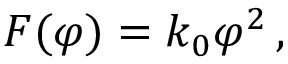<formula> <loc_0><loc_0><loc_500><loc_500>F ( \varphi ) = k _ { 0 } { \varphi } ^ { 2 } \, ,</formula> 